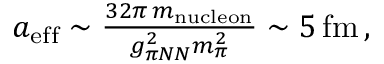Convert formula to latex. <formula><loc_0><loc_0><loc_500><loc_500>\begin{array} { r } { a _ { e f f } \sim \frac { 3 2 \pi \, m _ { n u c l e o n } } { g _ { \pi N N } ^ { 2 } m _ { \pi } ^ { 2 } } \sim 5 \, f m \, , } \end{array}</formula> 